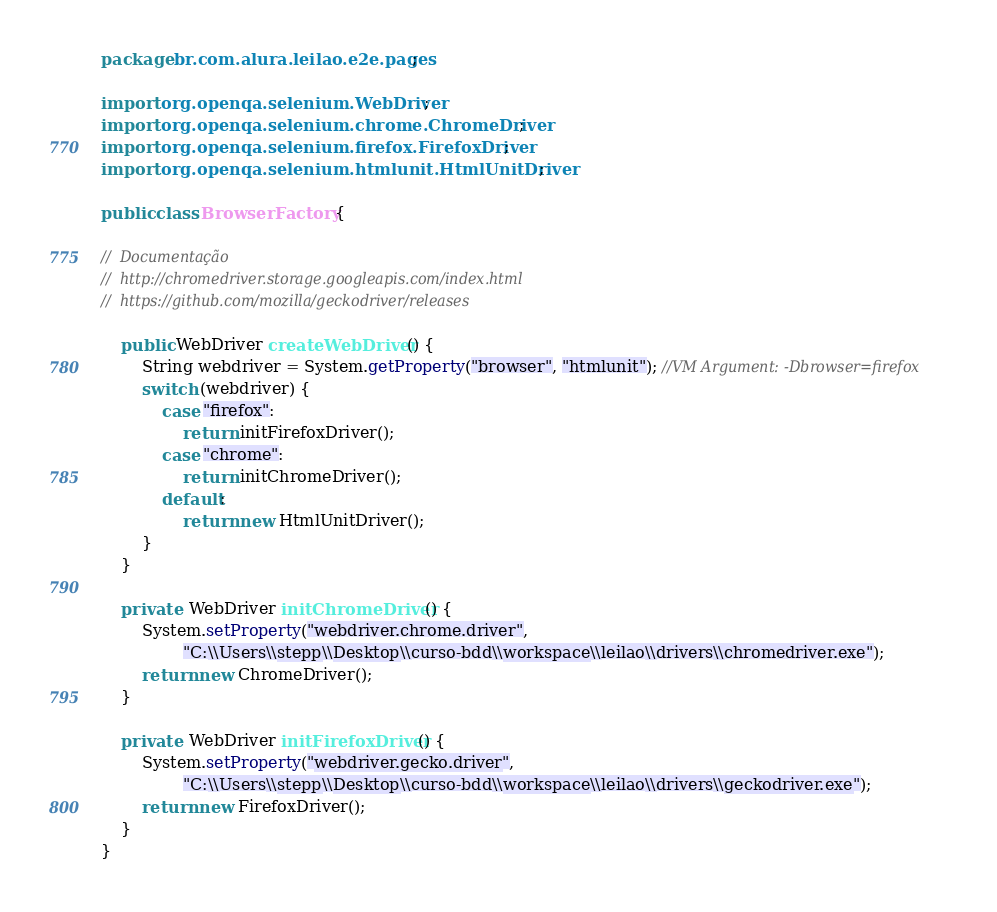Convert code to text. <code><loc_0><loc_0><loc_500><loc_500><_Java_>package br.com.alura.leilao.e2e.pages;

import org.openqa.selenium.WebDriver;
import org.openqa.selenium.chrome.ChromeDriver;
import org.openqa.selenium.firefox.FirefoxDriver;
import org.openqa.selenium.htmlunit.HtmlUnitDriver;

public class BrowserFactory {

//  Documentação
//	http://chromedriver.storage.googleapis.com/index.html
//	https://github.com/mozilla/geckodriver/releases	

	public WebDriver createWebDriver() {
		String webdriver = System.getProperty("browser", "htmlunit"); //VM Argument: -Dbrowser=firefox
		switch (webdriver) {
			case "firefox":
				return initFirefoxDriver();
			case "chrome":
				return initChromeDriver();
			default:
				return new HtmlUnitDriver();
		}
	}

	private  WebDriver initChromeDriver() {
		System.setProperty("webdriver.chrome.driver",
				"C:\\Users\\stepp\\Desktop\\curso-bdd\\workspace\\leilao\\drivers\\chromedriver.exe");
		return new ChromeDriver();
	}

	private  WebDriver initFirefoxDriver() {
		System.setProperty("webdriver.gecko.driver",
				"C:\\Users\\stepp\\Desktop\\curso-bdd\\workspace\\leilao\\drivers\\geckodriver.exe");
		return new FirefoxDriver();
	}
}
</code> 